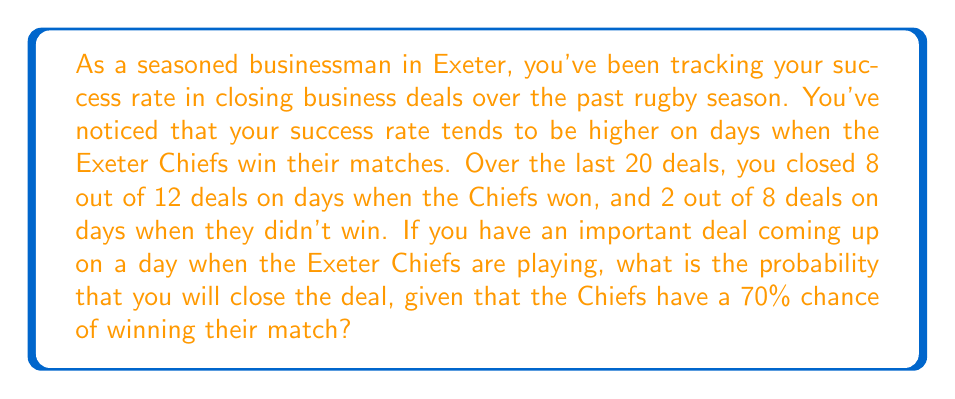Can you answer this question? Let's approach this step-by-step using the law of total probability:

1) Define events:
   A: Closing the deal
   W: Chiefs win
   L: Chiefs lose

2) Given probabilities:
   P(W) = 0.70
   P(L) = 1 - P(W) = 0.30
   P(A|W) = 8/12 = 2/3
   P(A|L) = 2/8 = 1/4

3) Use the law of total probability:
   $$P(A) = P(A|W) \cdot P(W) + P(A|L) \cdot P(L)$$

4) Substitute the values:
   $$P(A) = \frac{2}{3} \cdot 0.70 + \frac{1}{4} \cdot 0.30$$

5) Calculate:
   $$P(A) = 0.4667 + 0.0750 = 0.5417$$

Therefore, the probability of closing the deal is approximately 0.5417 or 54.17%.
Answer: The probability of closing the deal is approximately 0.5417 or 54.17%. 